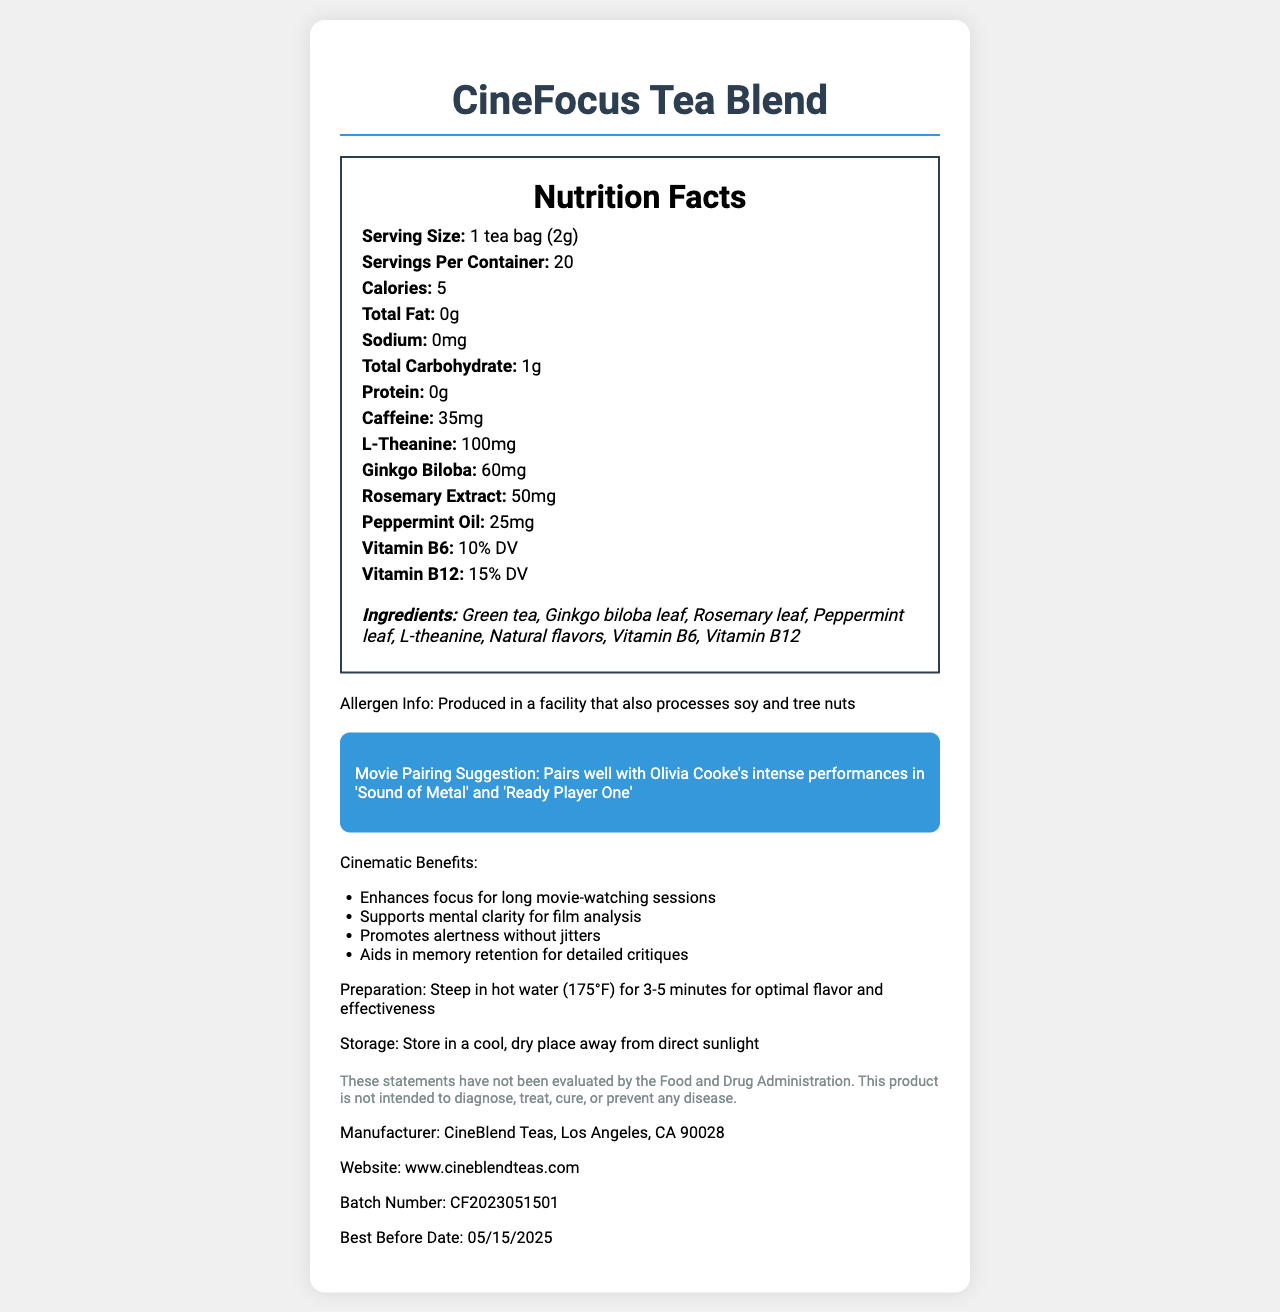what is the serving size of the tea? According to the nutrition label, the serving size is specified as "1 tea bag (2g)."
Answer: 1 tea bag (2g) how many calories are in each serving? The nutrition label specifies that there are 5 calories per serving.
Answer: 5 how much caffeine does each serving contain? The label lists the caffeine content, which is 35 mg per serving.
Answer: 35 mg which vitamins are included in the CineFocus Tea Blend? The nutrition label mentions both Vitamin B6 and Vitamin B12 as part of the ingredients.
Answer: Vitamin B6 and Vitamin B12 what is the movie pairing suggestion for this tea? The document specifically states this pairing suggestion in the movie pairing section.
Answer: Pairs well with Olivia Cooke's intense performances in 'Sound of Metal' and 'Ready Player One' what are some cinematic benefits of the CineFocus Tea Blend? The cinematic benefits section lists these four benefits.
Answer: Enhances focus for long movie-watching sessions, Supports mental clarity for film analysis, Promotes alertness without jitters, Aids in memory retention for detailed critiques how many servings are there per container? The nutrition label indicates that there are 20 servings per container.
Answer: 20 what is the total carbohydrate content per serving? The total carbohydrate content per serving is listed as 1g.
Answer: 1g which ingredient is included in the largest amount based on weight? A. Rosemary Extract B. Ginkgo Biloba C. L-theanine The nutrition label shows that L-theanine is included at 100 mg, which is the highest quantity among the listed ingredients with specific weights.
Answer: C. L-theanine where should the tea be stored? A. In a freezer B. In a cool, dry place away from direct sunlight C. In the refrigerator D. Under direct sunlight The storage instructions specify that the tea should be stored in a cool, dry place away from direct sunlight.
Answer: B. In a cool, dry place away from direct sunlight is this product suitable for someone with a soy allergy? The allergen info states that it is produced in a facility that processes soy, making it potentially unsuitable for someone with a soy allergy.
Answer: No summarize the main purpose and highlights of the CineFocus Tea Blend. The document describes the tea blend's primary benefits, focus on cinema, nutritional content, ingredient list, movie pairing suggestions, and storage instructions.
Answer: The CineFocus Tea Blend is a specialty tea designed to enhance focus during long movie-watching sessions. It contains 5 calories per serving and includes ingredients such as green tea, ginkgo biloba, rosemary, peppermint, L-theanine, and vitamins B6 and B12. The tea is suggested to pair well with Olivia Cooke's performances and offers benefits like enhancing focus, supporting mental clarity, promoting alertness without jitters, and aiding memory retention. It should be stored in a cool, dry place and is produced in a facility that processes soy and tree nuts. who is the manufacturer of this tea? The manufacturer information provided in the document states CineBlend Teas, Los Angeles, CA 90028.
Answer: CineBlend Teas, Los Angeles, CA 90028 can this product cure any diseases? The disclaimer mentions that the statements have not been evaluated by the Food and Drug Administration and that the product is not intended to diagnose, treat, cure, or prevent any disease.
Answer: No what is the percentage daily value of Vitamin B12 in each serving? According to the nutrition facts section, the percentage daily value of Vitamin B12 is 15%.
Answer: 15% DV what is the batch number for this product? The batch number for the CineFocus Tea Blend is listed as CF2023051501.
Answer: CF2023051501 what is Olivia Cooke's role in the movie 'Ready Player One'? The document does not provide any information about Olivia Cooke's role in 'Ready Player One.'
Answer: Not enough information 